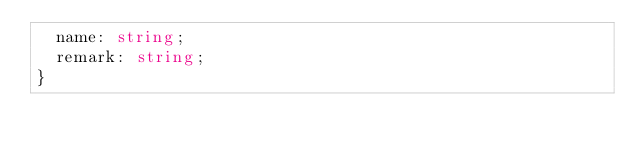Convert code to text. <code><loc_0><loc_0><loc_500><loc_500><_TypeScript_>  name: string;
  remark: string;
}
</code> 